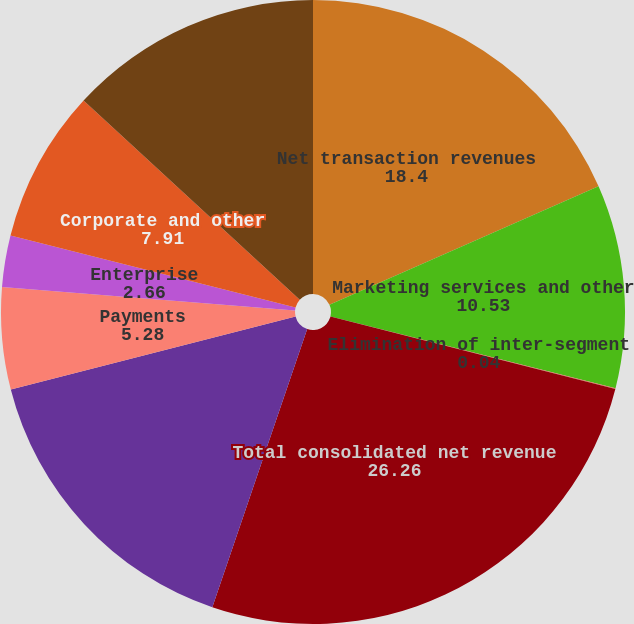<chart> <loc_0><loc_0><loc_500><loc_500><pie_chart><fcel>Net transaction revenues<fcel>Marketing services and other<fcel>Elimination of inter-segment<fcel>Total consolidated net revenue<fcel>Marketplaces<fcel>Payments<fcel>Enterprise<fcel>Corporate and other<fcel>Total operating income (loss)<nl><fcel>18.4%<fcel>10.53%<fcel>0.04%<fcel>26.26%<fcel>15.77%<fcel>5.28%<fcel>2.66%<fcel>7.91%<fcel>13.15%<nl></chart> 